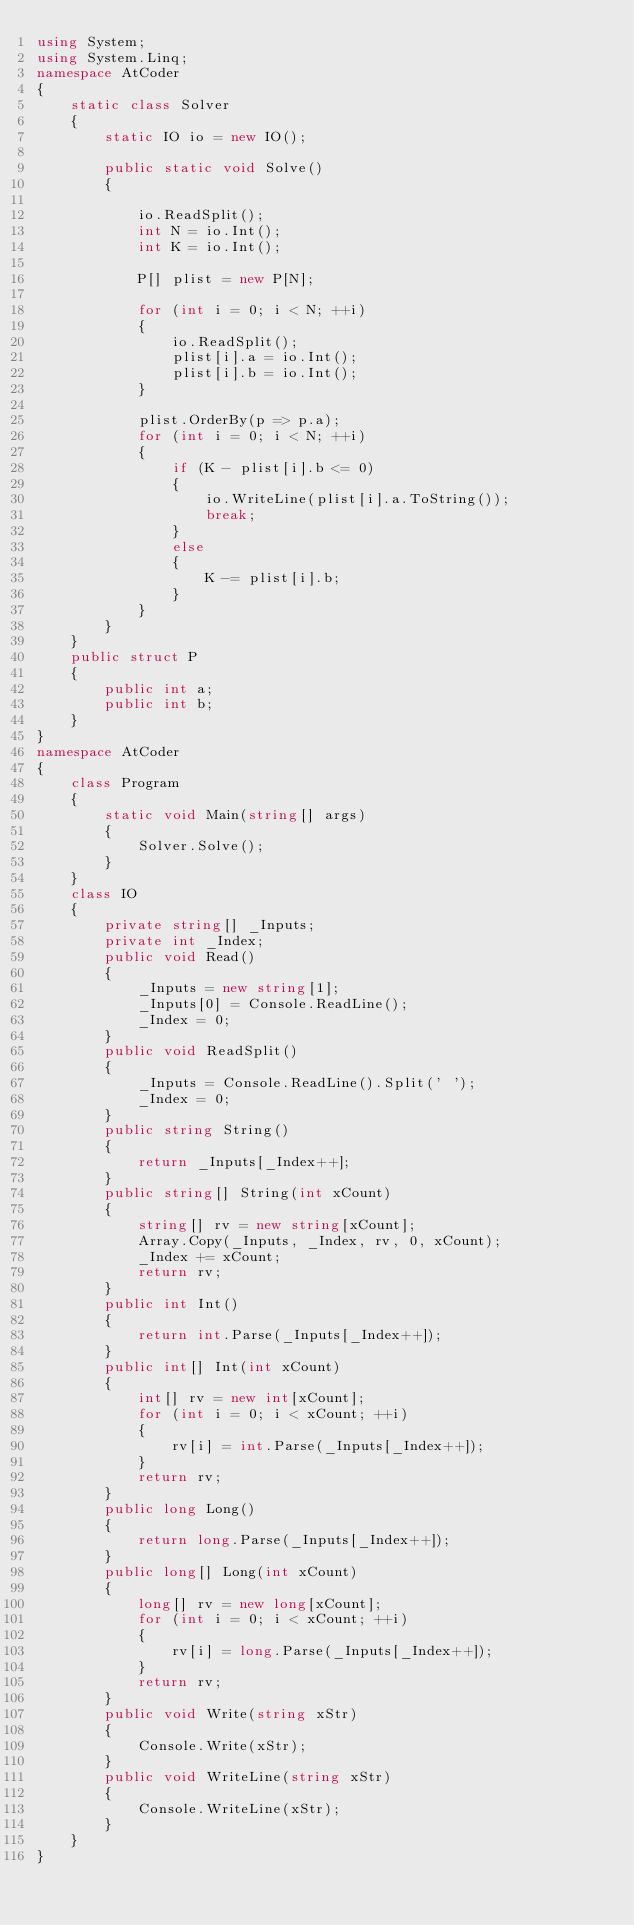<code> <loc_0><loc_0><loc_500><loc_500><_C#_>using System;
using System.Linq;
namespace AtCoder
{
    static class Solver
    {
        static IO io = new IO();

        public static void Solve()
        {

            io.ReadSplit();
            int N = io.Int();
            int K = io.Int();

            P[] plist = new P[N];

            for (int i = 0; i < N; ++i)
            {
                io.ReadSplit();
                plist[i].a = io.Int();
                plist[i].b = io.Int();
            }

            plist.OrderBy(p => p.a);
            for (int i = 0; i < N; ++i)
            {
                if (K - plist[i].b <= 0)
                {
                    io.WriteLine(plist[i].a.ToString());
                    break;
                }
                else
                {
                    K -= plist[i].b;
                }
            }
        }
    }
    public struct P
    {
        public int a;
        public int b;
    }
}
namespace AtCoder
{
    class Program
    {
        static void Main(string[] args)
        {
            Solver.Solve();
        }
    }
    class IO
    {
        private string[] _Inputs;
        private int _Index;
        public void Read()
        {
            _Inputs = new string[1];
            _Inputs[0] = Console.ReadLine();
            _Index = 0;
        }
        public void ReadSplit()
        {
            _Inputs = Console.ReadLine().Split(' ');
            _Index = 0;
        }
        public string String()
        {
            return _Inputs[_Index++];
        }
        public string[] String(int xCount)
        {
            string[] rv = new string[xCount];
            Array.Copy(_Inputs, _Index, rv, 0, xCount);
            _Index += xCount;
            return rv;
        }
        public int Int()
        {
            return int.Parse(_Inputs[_Index++]);
        }
        public int[] Int(int xCount)
        {
            int[] rv = new int[xCount];
            for (int i = 0; i < xCount; ++i)
            {
                rv[i] = int.Parse(_Inputs[_Index++]);
            }
            return rv;
        }
        public long Long()
        {
            return long.Parse(_Inputs[_Index++]);
        }
        public long[] Long(int xCount)
        {
            long[] rv = new long[xCount];
            for (int i = 0; i < xCount; ++i)
            {
                rv[i] = long.Parse(_Inputs[_Index++]);
            }
            return rv;
        }
        public void Write(string xStr)
        {
            Console.Write(xStr);
        }
        public void WriteLine(string xStr)
        {
            Console.WriteLine(xStr);
        }
    }
}</code> 